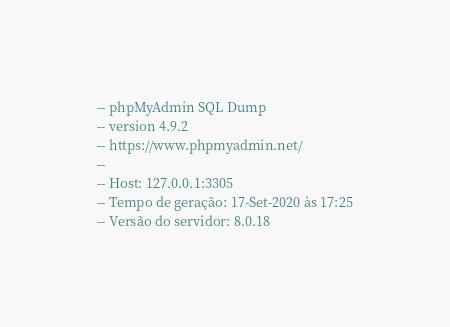<code> <loc_0><loc_0><loc_500><loc_500><_SQL_>-- phpMyAdmin SQL Dump
-- version 4.9.2
-- https://www.phpmyadmin.net/
--
-- Host: 127.0.0.1:3305
-- Tempo de geração: 17-Set-2020 às 17:25
-- Versão do servidor: 8.0.18</code> 